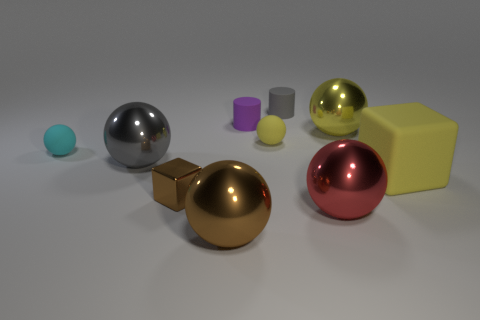What is the material of the small object that is the same color as the big rubber cube?
Your answer should be very brief. Rubber. There is another rubber thing that is the same shape as the purple thing; what is its color?
Your answer should be compact. Gray. What number of objects are either metallic balls or large things left of the small cube?
Your answer should be very brief. 4. Is the number of gray metallic spheres behind the cyan rubber thing less than the number of big things?
Your response must be concise. Yes. There is a cube that is to the right of the gray cylinder left of the big yellow object that is left of the big yellow rubber cube; what size is it?
Ensure brevity in your answer.  Large. There is a large thing that is to the left of the small purple cylinder and to the right of the gray metal thing; what color is it?
Your answer should be compact. Brown. What number of big blue cylinders are there?
Make the answer very short. 0. Is the cyan object made of the same material as the brown sphere?
Offer a very short reply. No. Is the size of the brown object behind the large brown thing the same as the yellow matte thing on the right side of the large yellow ball?
Your answer should be very brief. No. Is the number of tiny purple metallic cylinders less than the number of big yellow shiny things?
Keep it short and to the point. Yes. 